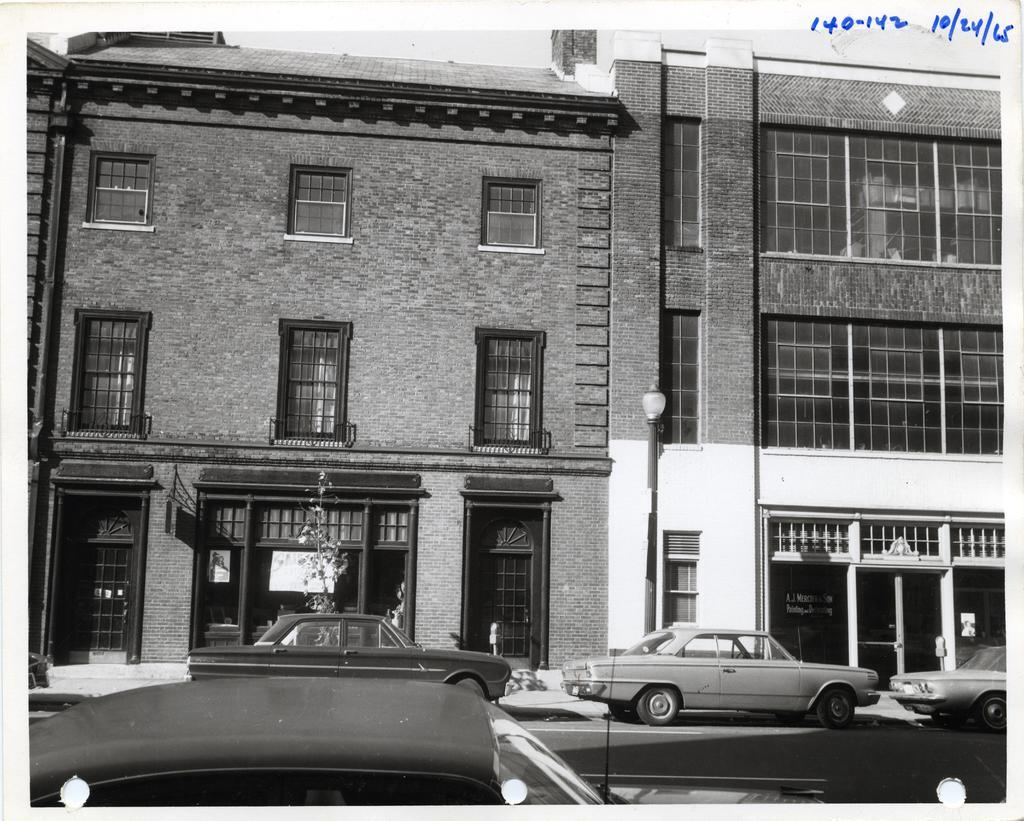What is happening on the road in the image? There are vehicles on the road in the image. What can be seen in the distance behind the vehicles? There are buildings visible in the background of the image. Can you describe any other objects in the background? There are some objects in the background of the image. Where are the numbers located in the image? The numbers are present in the top right corner of the image. Is there a jail visible in the image? No, there is no jail present in the image. How many doors can be seen on the buildings in the image? The image does not provide enough detail to count the number of doors on the buildings. 